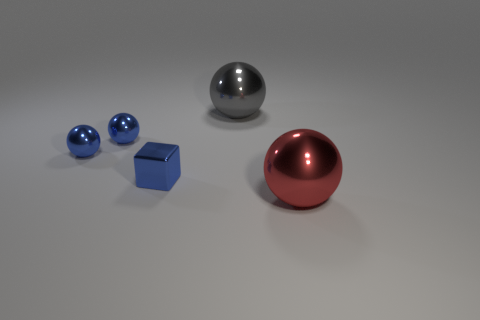Subtract all gray spheres. How many spheres are left? 3 Add 3 red blocks. How many objects exist? 8 Subtract all gray balls. How many balls are left? 3 Subtract 1 cubes. How many cubes are left? 0 Subtract 0 brown cubes. How many objects are left? 5 Subtract all balls. How many objects are left? 1 Subtract all yellow balls. Subtract all green cylinders. How many balls are left? 4 Subtract all yellow cubes. How many gray balls are left? 1 Subtract all shiny blocks. Subtract all big red metallic spheres. How many objects are left? 3 Add 3 blue balls. How many blue balls are left? 5 